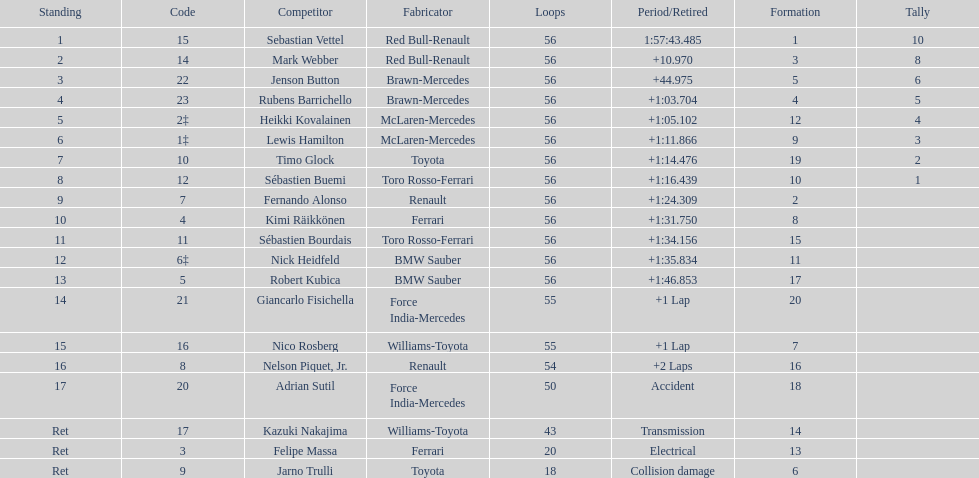How many laps in total is the race? 56. 